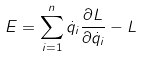<formula> <loc_0><loc_0><loc_500><loc_500>E = \sum _ { i = 1 } ^ { n } \dot { q } _ { i } \frac { \partial L } { \partial \dot { q } _ { i } } - L</formula> 